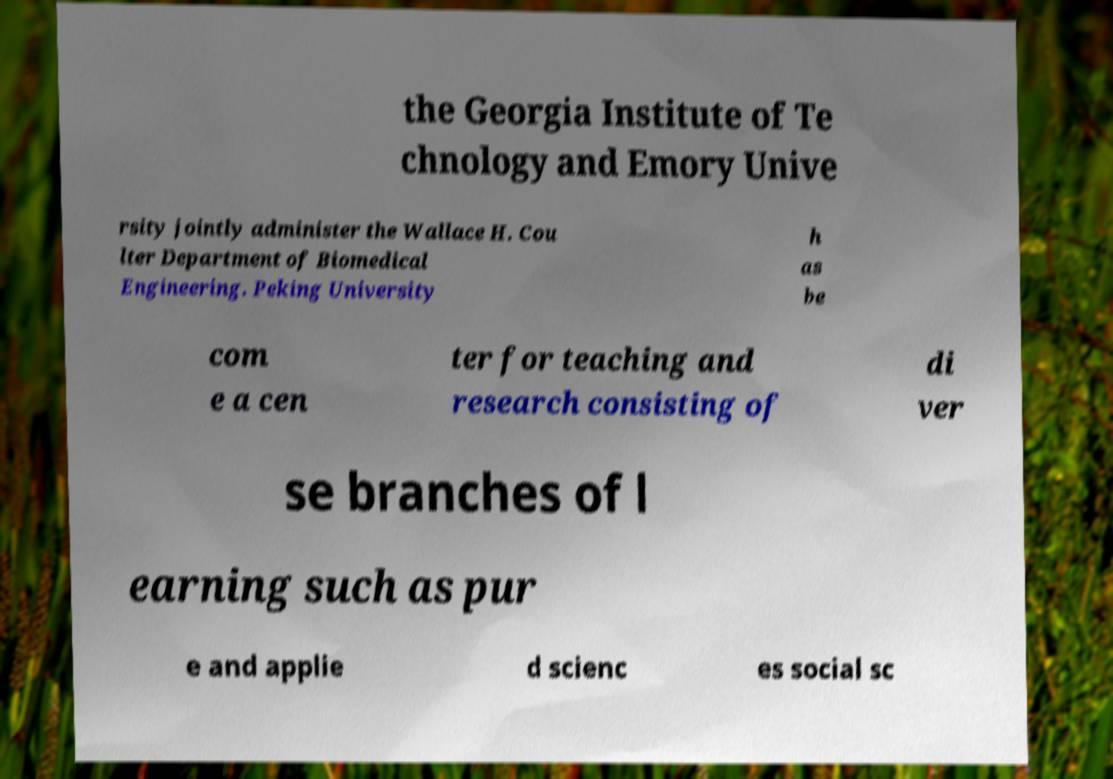Please identify and transcribe the text found in this image. the Georgia Institute of Te chnology and Emory Unive rsity jointly administer the Wallace H. Cou lter Department of Biomedical Engineering. Peking University h as be com e a cen ter for teaching and research consisting of di ver se branches of l earning such as pur e and applie d scienc es social sc 